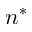<formula> <loc_0><loc_0><loc_500><loc_500>n ^ { * }</formula> 